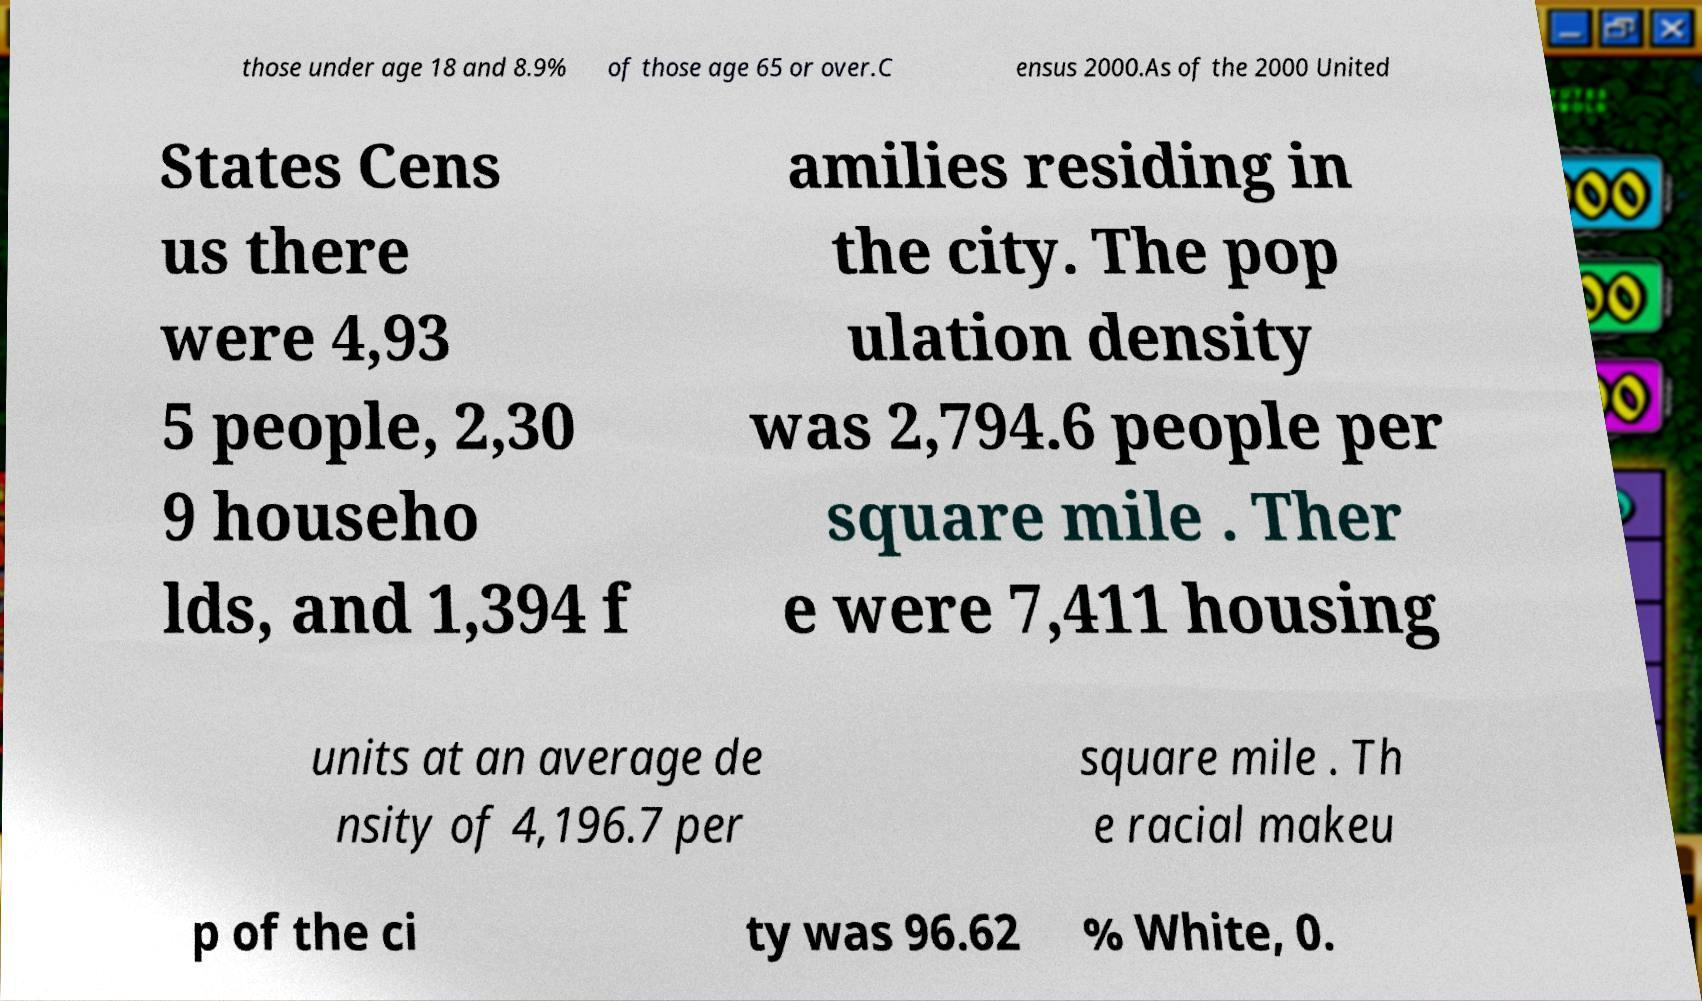Please read and relay the text visible in this image. What does it say? those under age 18 and 8.9% of those age 65 or over.C ensus 2000.As of the 2000 United States Cens us there were 4,93 5 people, 2,30 9 househo lds, and 1,394 f amilies residing in the city. The pop ulation density was 2,794.6 people per square mile . Ther e were 7,411 housing units at an average de nsity of 4,196.7 per square mile . Th e racial makeu p of the ci ty was 96.62 % White, 0. 